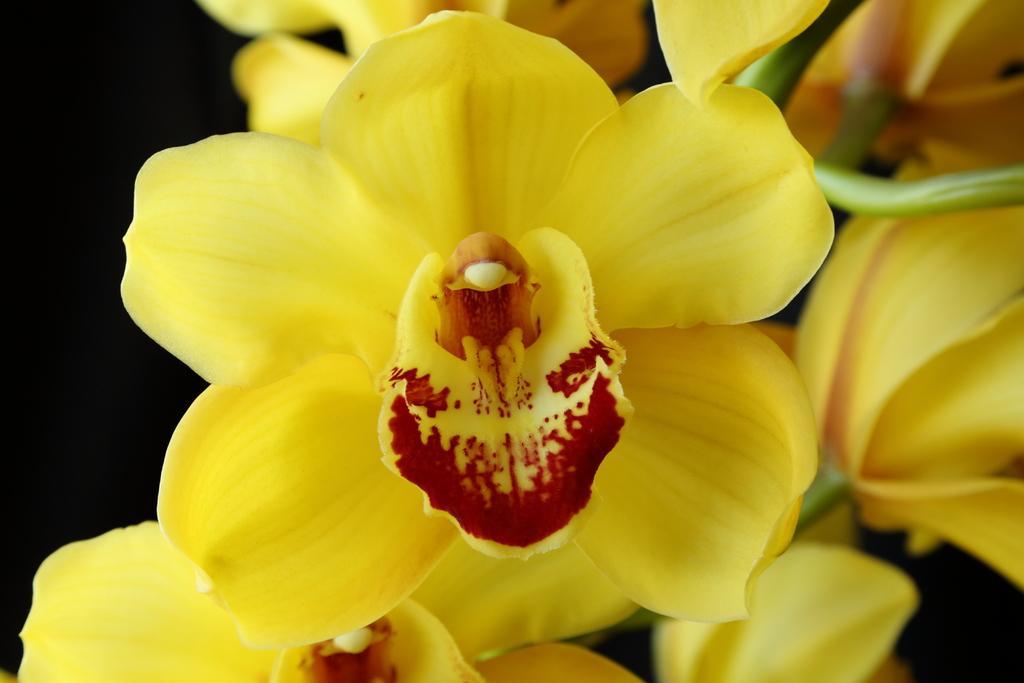Can you describe this image briefly? In this image there are yellow flowers, and there is dark background. 